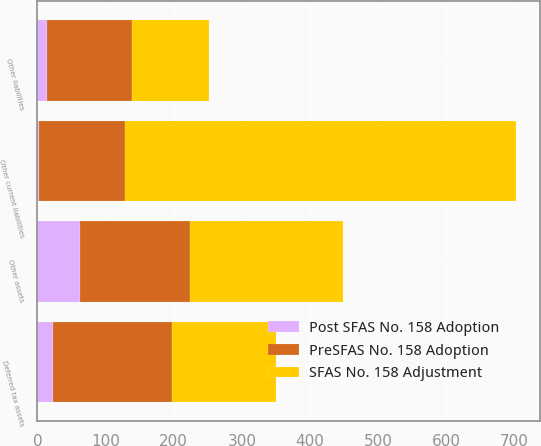<chart> <loc_0><loc_0><loc_500><loc_500><stacked_bar_chart><ecel><fcel>Deferred tax assets<fcel>Other assets<fcel>Other current liabilities<fcel>Other liabilities<nl><fcel>SFAS No. 158 Adjustment<fcel>152.8<fcel>224.4<fcel>573.9<fcel>112.5<nl><fcel>Post SFAS No. 158 Adoption<fcel>22.6<fcel>62.8<fcel>2.3<fcel>13.3<nl><fcel>PreSFAS No. 158 Adoption<fcel>175.4<fcel>161.6<fcel>125.8<fcel>125.8<nl></chart> 